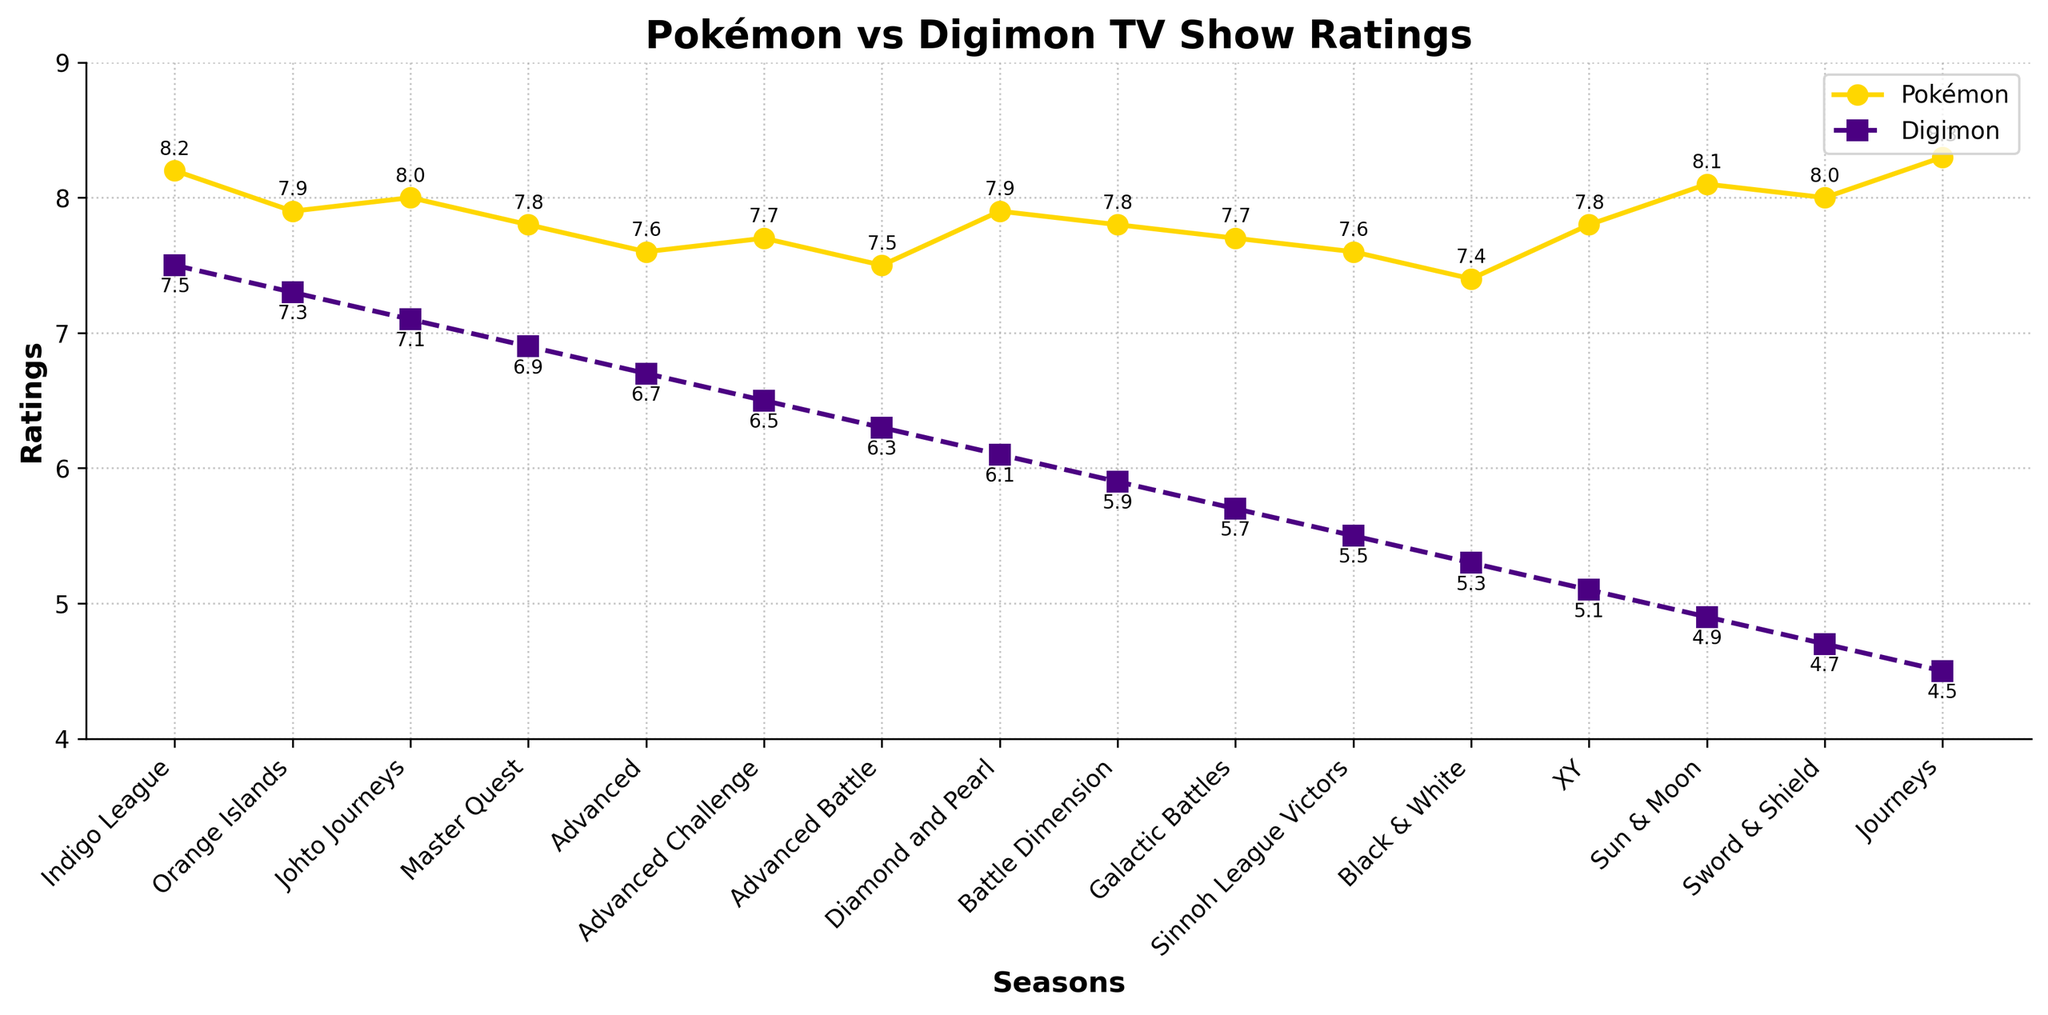What's the highest Pokémon rating across all seasons? To find the highest Pokémon rating, look at the yellow line with round markers and identify the peak value. The peak is at Season "Journeys" with a rating of 8.3.
Answer: 8.3 Which season shows the largest difference between Pokémon and Digimon ratings? To find the largest difference, subtract each Digimon rating (dashed purple line with square markers) from the corresponding Pokémon rating. The largest difference is in "Journeys" where Pokémon has 8.3 and Digimon has 4.5, giving a difference of 3.8.
Answer: Journeys How did Pokémon and Digimon ratings compare during the "Diamond and Pearl" season? For "Diamond and Pearl", Pokémon is at 7.9 (yellow line), and Digimon is at 6.1 (purple line). Pokémon ratings were higher than Digimon.
Answer: Pokémon higher In which season did Pokémon and Digimon ratings both show a decline compared to the previous season? Both lines need to be downward from one season to the next. For instance, from "Johto Journeys" to "Master Quest", Pokémon declined from 8.0 to 7.8, and Digimon from 7.1 to 6.9.
Answer: Master Quest Which season had the highest rating for Digimon? Look at the peak of the purple dashed line with square markers. The Season "Indigo League" has the highest rating for Digimon at 7.5.
Answer: Indigo League What's the difference in ratings between Pokémon's "Sun & Moon" and "Sword & Shield"? Locate the ratings for these seasons: "Sun & Moon" has 8.1, and "Sword & Shield" has 8.0. Subtracting gives a difference of 0.1.
Answer: 0.1 In what season did Digimon ratings fall below 5? Observe the purple line and identify when it dips below 5. This is first seen in "Black & White" with a rating of 5.3.
Answer: Black & White Between which two consecutive seasons did Pokémon see the smallest decline in ratings? Check the yellow line and find the smallest drop: "Sun & Moon" (8.1) to "Sword & Shield" (8.0) shows a decline of 0.1, the smallest decline.
Answer: Sun & Moon to Sword & Shield Which season marked a recovery in ratings for Pokémon after a decline in the previous season? Look for a rise in the yellow line after a drop: After "Black & White" (7.4), the next season "XY" rose to 7.8.
Answer: XY 